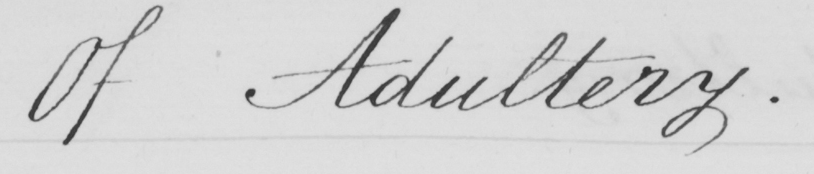What does this handwritten line say? Of Adultery . 